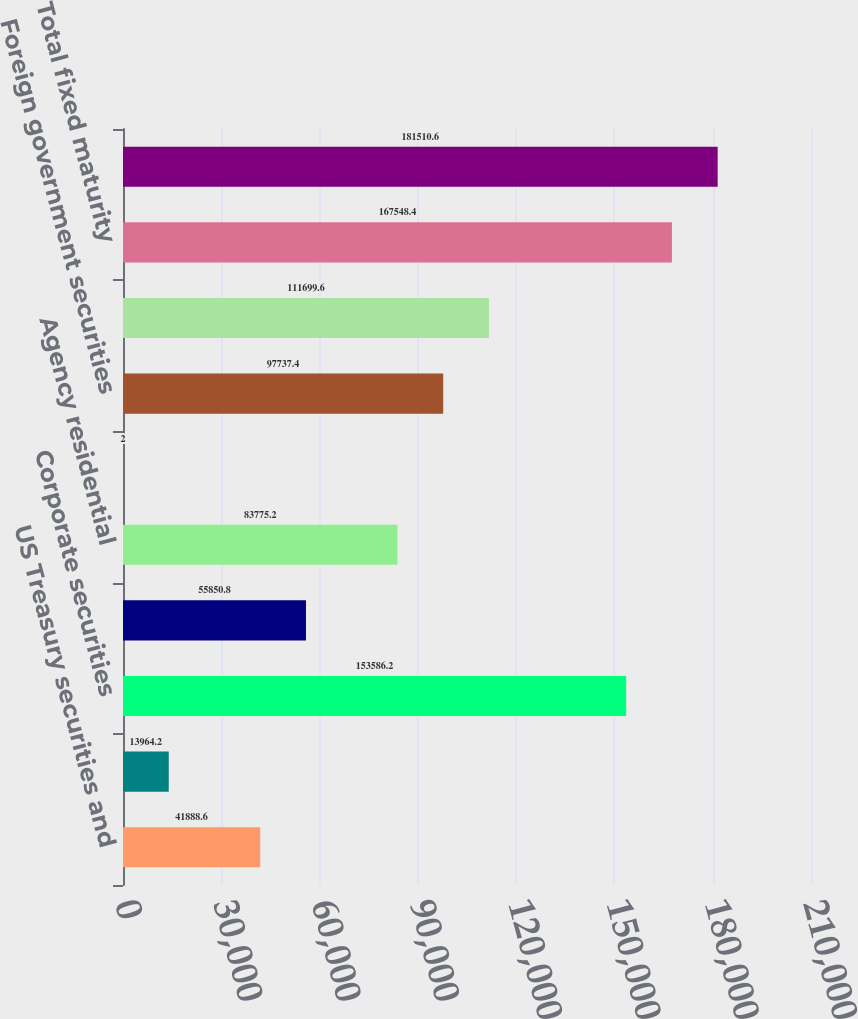<chart> <loc_0><loc_0><loc_500><loc_500><bar_chart><fcel>US Treasury securities and<fcel>Obligations of US states and<fcel>Corporate securities<fcel>Asset-backed securities<fcel>Agency residential<fcel>Non-agency residential<fcel>Foreign government securities<fcel>Foreign corporate securities<fcel>Total fixed maturity<fcel>Total<nl><fcel>41888.6<fcel>13964.2<fcel>153586<fcel>55850.8<fcel>83775.2<fcel>2<fcel>97737.4<fcel>111700<fcel>167548<fcel>181511<nl></chart> 